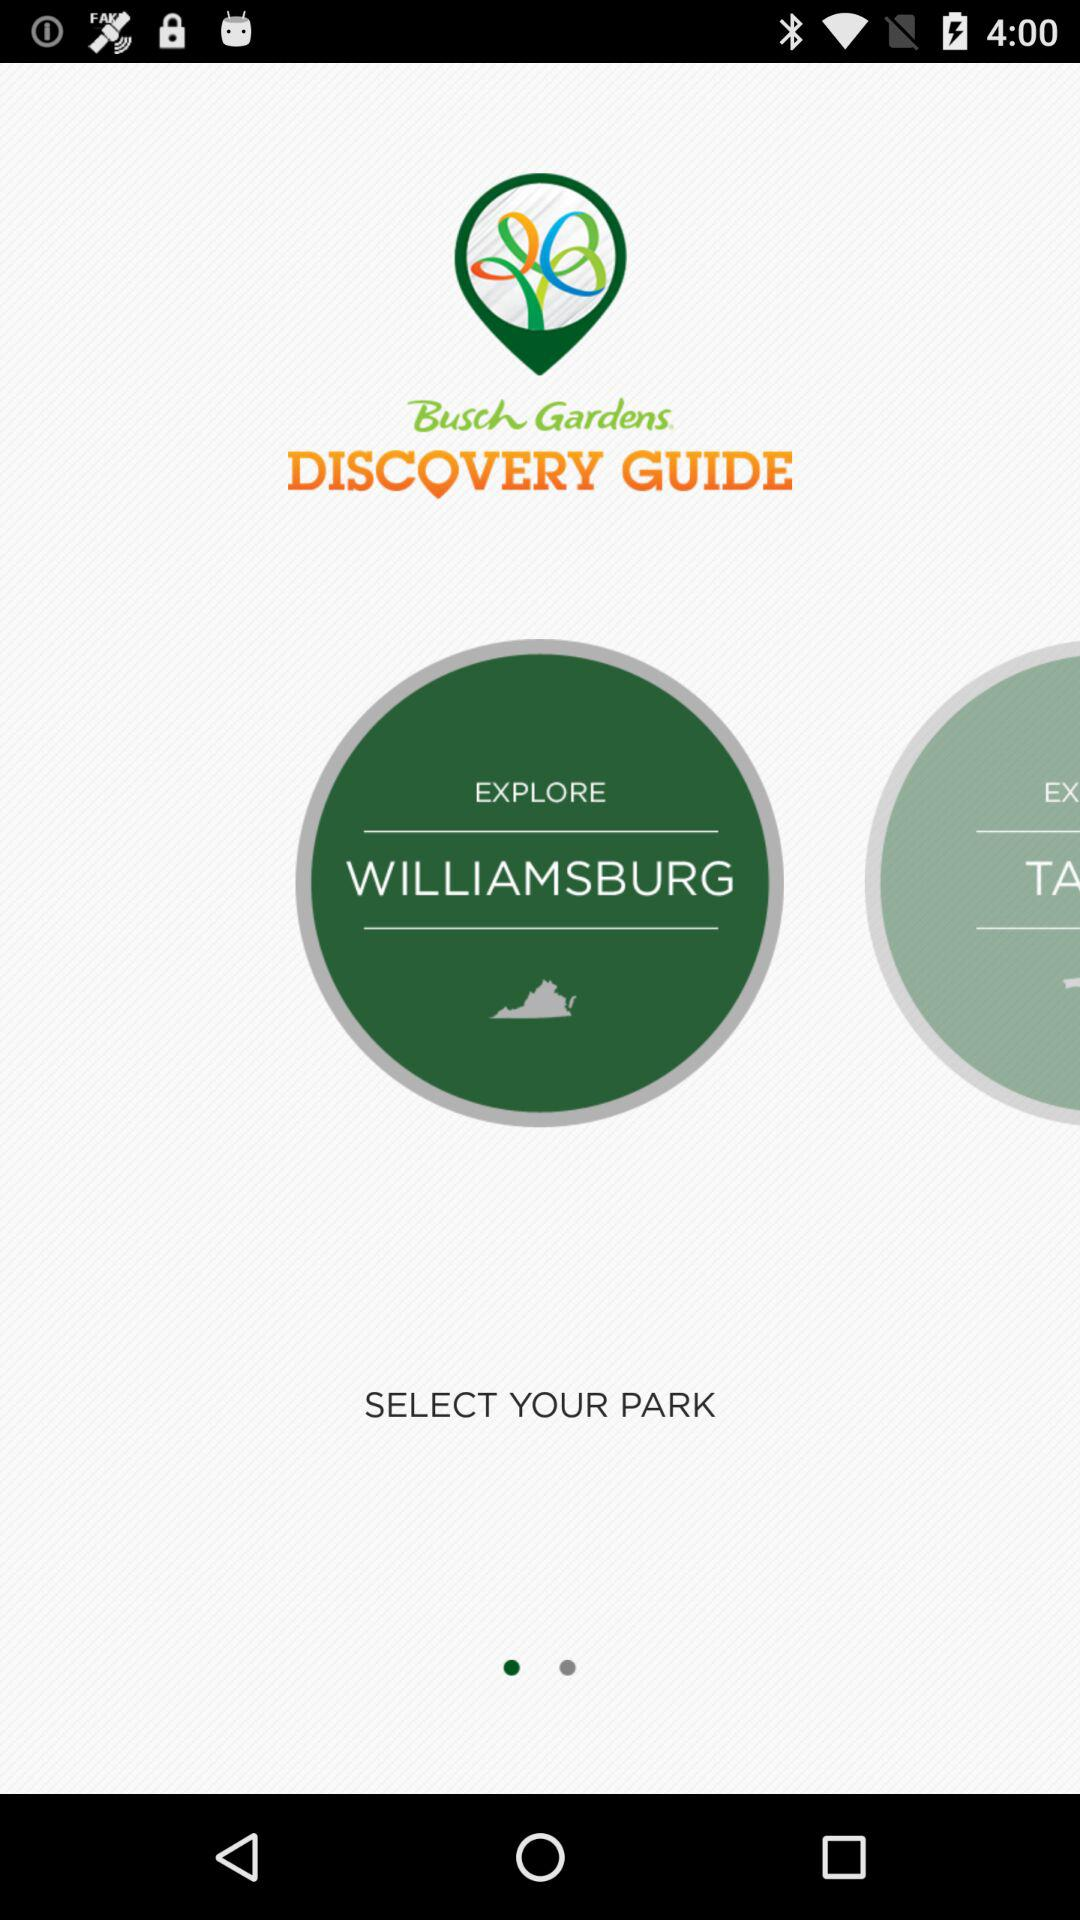What is the application name? The application name is "Busch Gardens". 